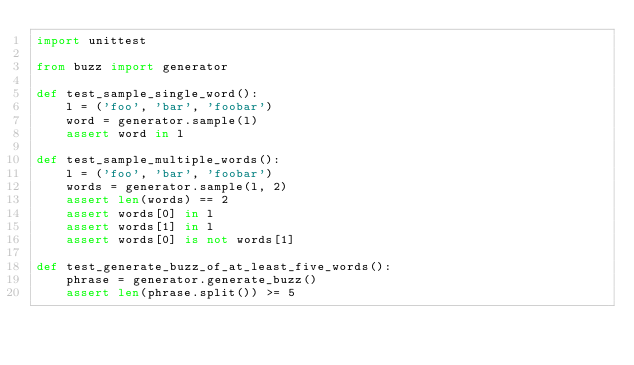Convert code to text. <code><loc_0><loc_0><loc_500><loc_500><_Python_>import unittest

from buzz import generator

def test_sample_single_word():
    l = ('foo', 'bar', 'foobar')
    word = generator.sample(l)
    assert word in l

def test_sample_multiple_words():
    l = ('foo', 'bar', 'foobar')
    words = generator.sample(l, 2)
    assert len(words) == 2
    assert words[0] in l
    assert words[1] in l
    assert words[0] is not words[1]

def test_generate_buzz_of_at_least_five_words():
    phrase = generator.generate_buzz()
    assert len(phrase.split()) >= 5
</code> 